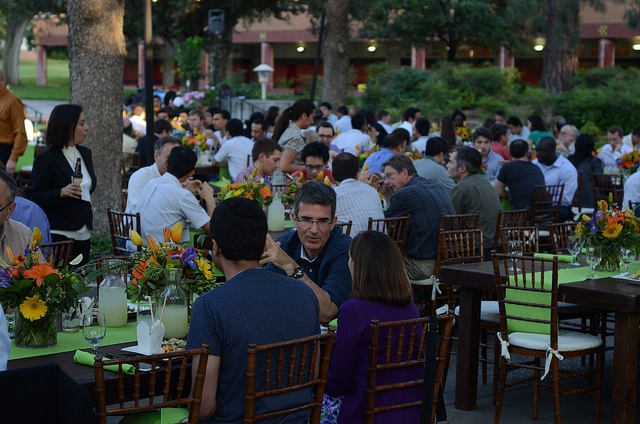Describe the objects in this image and their specific colors. I can see people in black, gray, darkgreen, and maroon tones, people in black, navy, maroon, and gray tones, chair in black, green, darkgray, and gray tones, dining table in black, green, and gray tones, and people in black, navy, and gray tones in this image. 